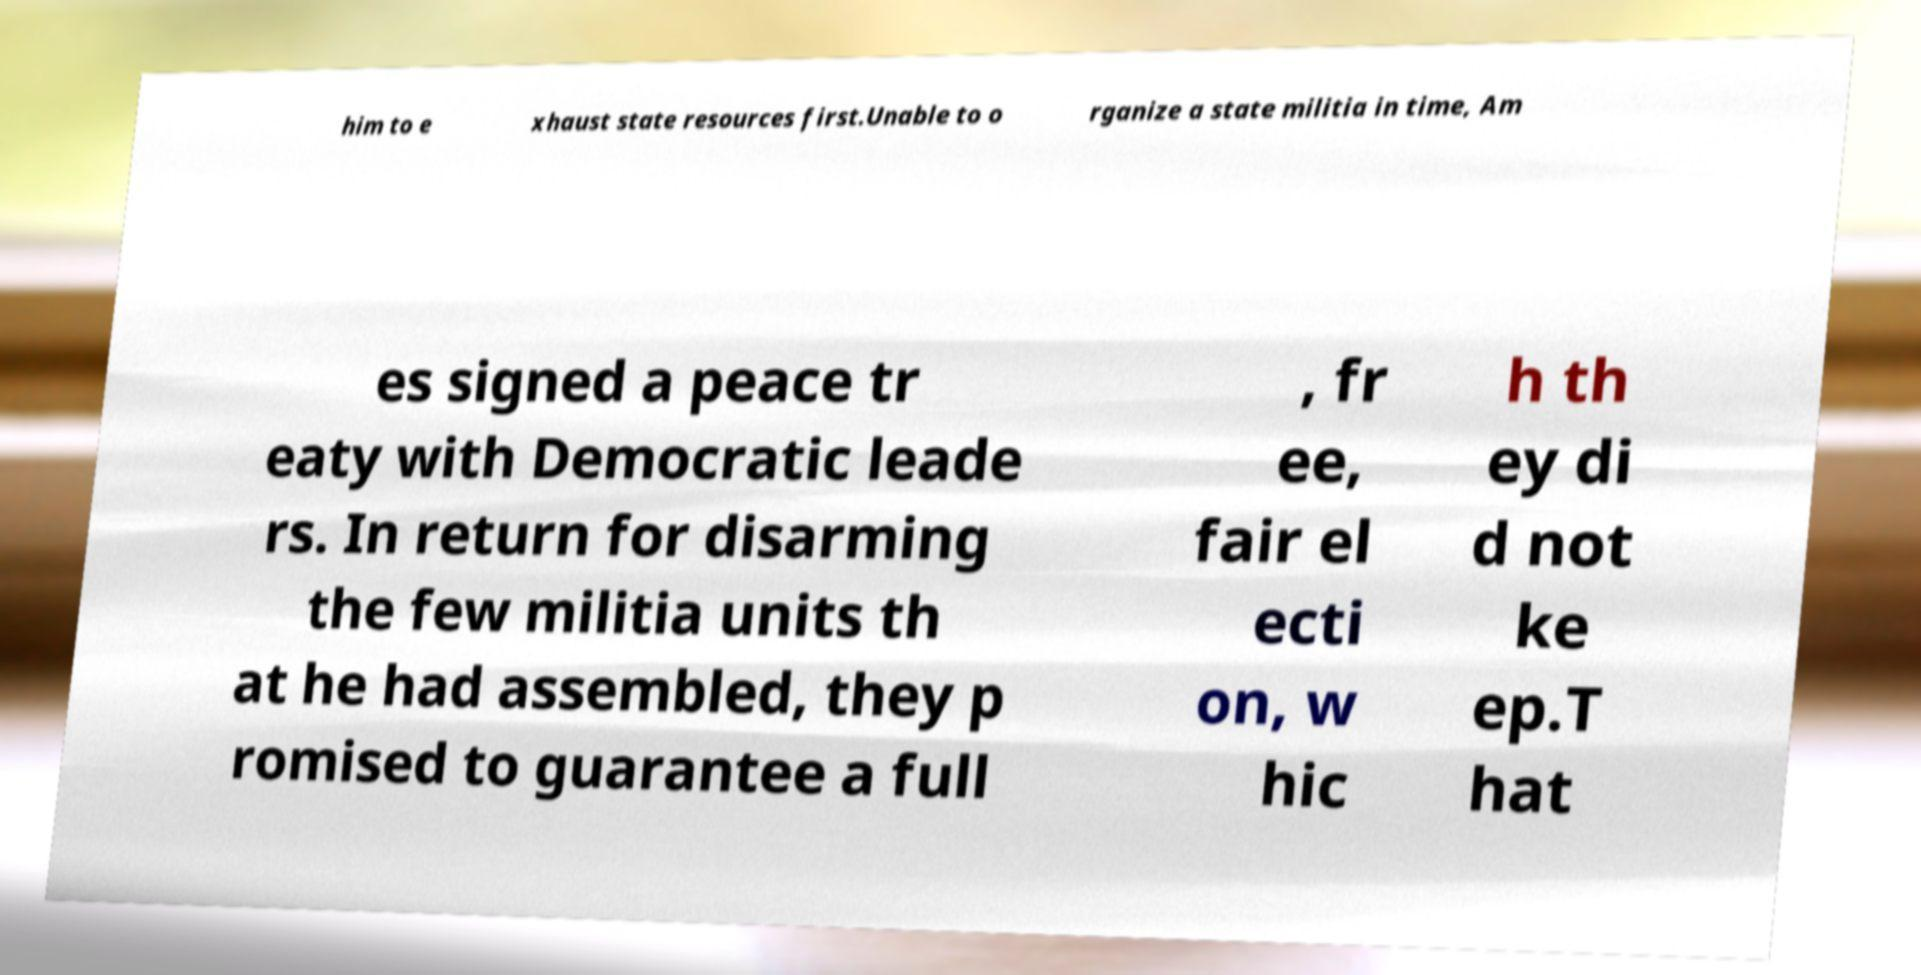There's text embedded in this image that I need extracted. Can you transcribe it verbatim? him to e xhaust state resources first.Unable to o rganize a state militia in time, Am es signed a peace tr eaty with Democratic leade rs. In return for disarming the few militia units th at he had assembled, they p romised to guarantee a full , fr ee, fair el ecti on, w hic h th ey di d not ke ep.T hat 